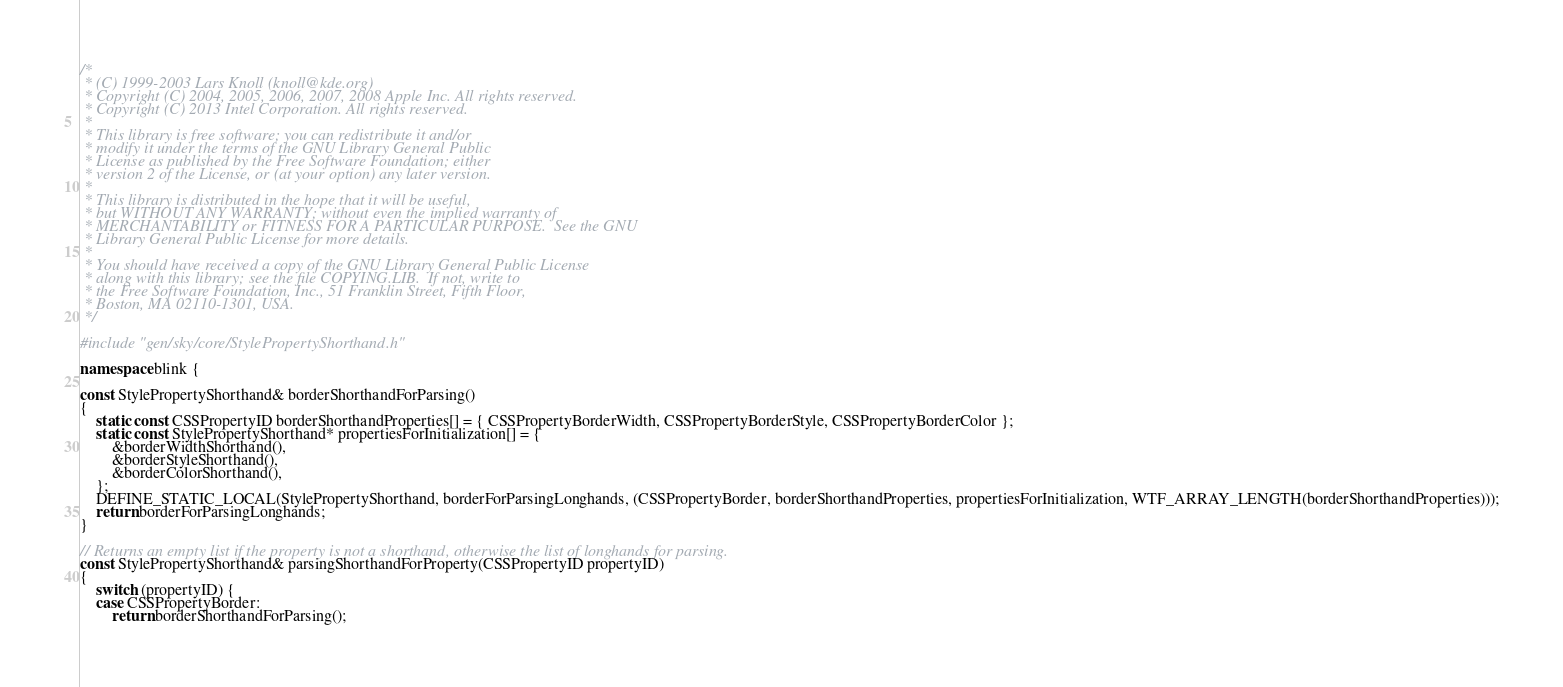<code> <loc_0><loc_0><loc_500><loc_500><_C++_>/*
 * (C) 1999-2003 Lars Knoll (knoll@kde.org)
 * Copyright (C) 2004, 2005, 2006, 2007, 2008 Apple Inc. All rights reserved.
 * Copyright (C) 2013 Intel Corporation. All rights reserved.
 *
 * This library is free software; you can redistribute it and/or
 * modify it under the terms of the GNU Library General Public
 * License as published by the Free Software Foundation; either
 * version 2 of the License, or (at your option) any later version.
 *
 * This library is distributed in the hope that it will be useful,
 * but WITHOUT ANY WARRANTY; without even the implied warranty of
 * MERCHANTABILITY or FITNESS FOR A PARTICULAR PURPOSE.  See the GNU
 * Library General Public License for more details.
 *
 * You should have received a copy of the GNU Library General Public License
 * along with this library; see the file COPYING.LIB.  If not, write to
 * the Free Software Foundation, Inc., 51 Franklin Street, Fifth Floor,
 * Boston, MA 02110-1301, USA.
 */

#include "gen/sky/core/StylePropertyShorthand.h"

namespace blink {

const StylePropertyShorthand& borderShorthandForParsing()
{
    static const CSSPropertyID borderShorthandProperties[] = { CSSPropertyBorderWidth, CSSPropertyBorderStyle, CSSPropertyBorderColor };
    static const StylePropertyShorthand* propertiesForInitialization[] = {
        &borderWidthShorthand(),
        &borderStyleShorthand(),
        &borderColorShorthand(),
    };
    DEFINE_STATIC_LOCAL(StylePropertyShorthand, borderForParsingLonghands, (CSSPropertyBorder, borderShorthandProperties, propertiesForInitialization, WTF_ARRAY_LENGTH(borderShorthandProperties)));
    return borderForParsingLonghands;
}

// Returns an empty list if the property is not a shorthand, otherwise the list of longhands for parsing.
const StylePropertyShorthand& parsingShorthandForProperty(CSSPropertyID propertyID)
{
    switch (propertyID) {
    case CSSPropertyBorder:
        return borderShorthandForParsing();</code> 